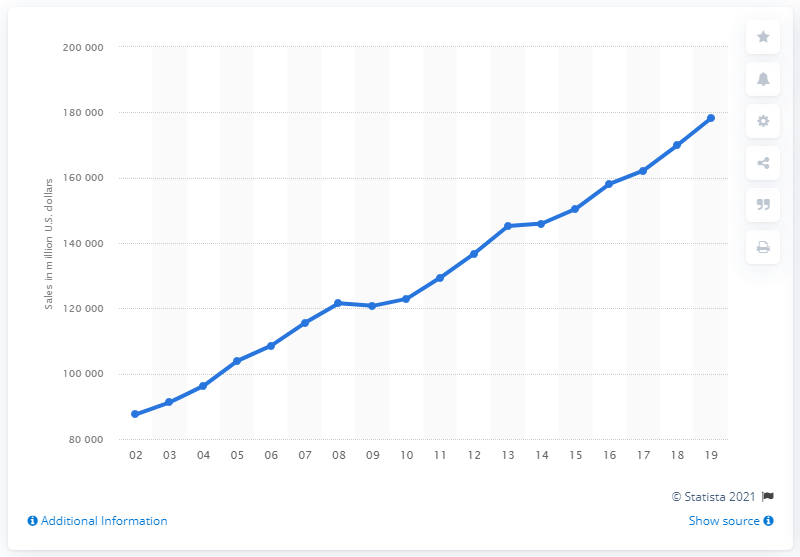Give some essential details in this illustration. According to data from U.S. merchant wholesalers in 2019, the sales of beer, wine, and distilled alcoholic beverages amounted to a total of 178,199 in value. 